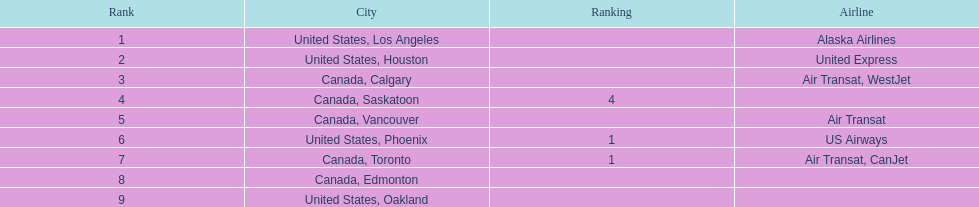What was the number of passengers in phoenix arizona? 1,829. 